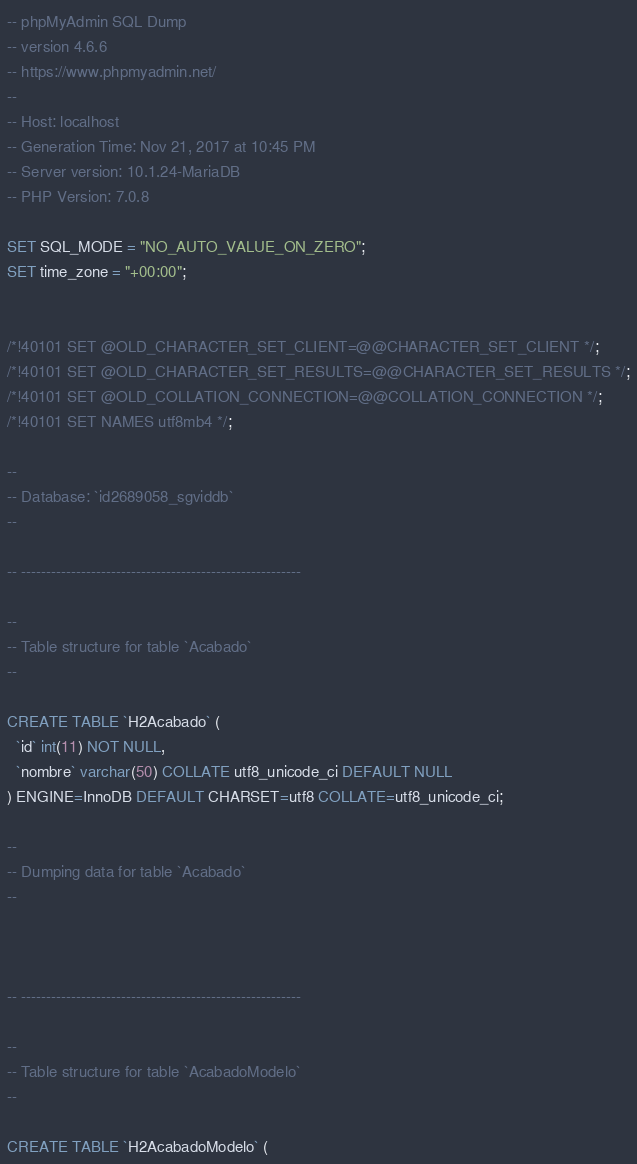<code> <loc_0><loc_0><loc_500><loc_500><_SQL_>-- phpMyAdmin SQL Dump
-- version 4.6.6
-- https://www.phpmyadmin.net/
--
-- Host: localhost
-- Generation Time: Nov 21, 2017 at 10:45 PM
-- Server version: 10.1.24-MariaDB
-- PHP Version: 7.0.8

SET SQL_MODE = "NO_AUTO_VALUE_ON_ZERO";
SET time_zone = "+00:00";


/*!40101 SET @OLD_CHARACTER_SET_CLIENT=@@CHARACTER_SET_CLIENT */;
/*!40101 SET @OLD_CHARACTER_SET_RESULTS=@@CHARACTER_SET_RESULTS */;
/*!40101 SET @OLD_COLLATION_CONNECTION=@@COLLATION_CONNECTION */;
/*!40101 SET NAMES utf8mb4 */;

--
-- Database: `id2689058_sgviddb`
--

-- --------------------------------------------------------

--
-- Table structure for table `Acabado`
--

CREATE TABLE `H2Acabado` (
  `id` int(11) NOT NULL,
  `nombre` varchar(50) COLLATE utf8_unicode_ci DEFAULT NULL
) ENGINE=InnoDB DEFAULT CHARSET=utf8 COLLATE=utf8_unicode_ci;

--
-- Dumping data for table `Acabado`
--



-- --------------------------------------------------------

--
-- Table structure for table `AcabadoModelo`
--

CREATE TABLE `H2AcabadoModelo` (</code> 